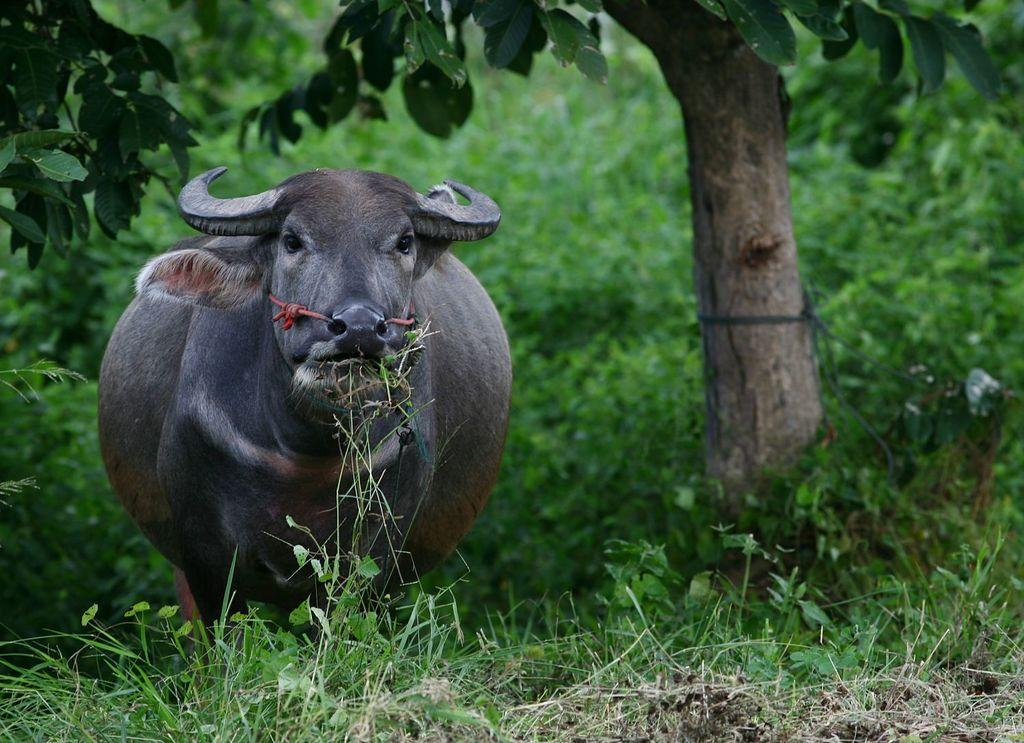What animal can be seen in the picture? There is a buffalo in the picture. What is the buffalo doing in the picture? The buffalo is grazing the grass. What type of vegetation is visible at the bottom of the picture? Grass and herbs are present at the bottom of the picture. What can be seen in the background of the picture? There are trees and herbs in the background of the picture. What type of bed can be seen in the picture? There is no bed present in the picture; it features a buffalo grazing in a grassy area with trees and herbs in the background. What parent is interacting with the buffalo in the picture? There are no humans or animals interacting with the buffalo in the picture. 